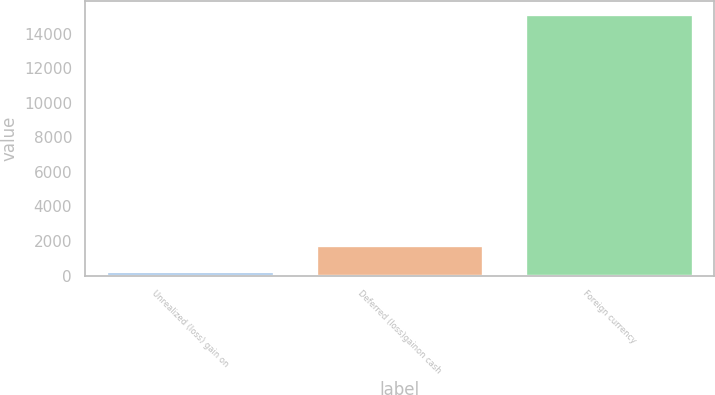Convert chart to OTSL. <chart><loc_0><loc_0><loc_500><loc_500><bar_chart><fcel>Unrealized (loss) gain on<fcel>Deferred (loss)gainon cash<fcel>Foreign currency<nl><fcel>250<fcel>1740.9<fcel>15159<nl></chart> 